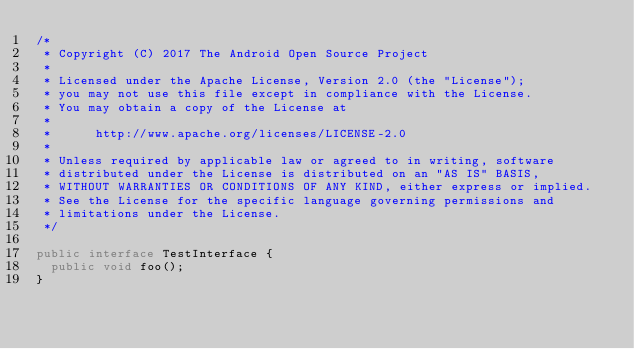Convert code to text. <code><loc_0><loc_0><loc_500><loc_500><_Java_>/*
 * Copyright (C) 2017 The Android Open Source Project
 *
 * Licensed under the Apache License, Version 2.0 (the "License");
 * you may not use this file except in compliance with the License.
 * You may obtain a copy of the License at
 *
 *      http://www.apache.org/licenses/LICENSE-2.0
 *
 * Unless required by applicable law or agreed to in writing, software
 * distributed under the License is distributed on an "AS IS" BASIS,
 * WITHOUT WARRANTIES OR CONDITIONS OF ANY KIND, either express or implied.
 * See the License for the specific language governing permissions and
 * limitations under the License.
 */

public interface TestInterface {
  public void foo();
}
</code> 